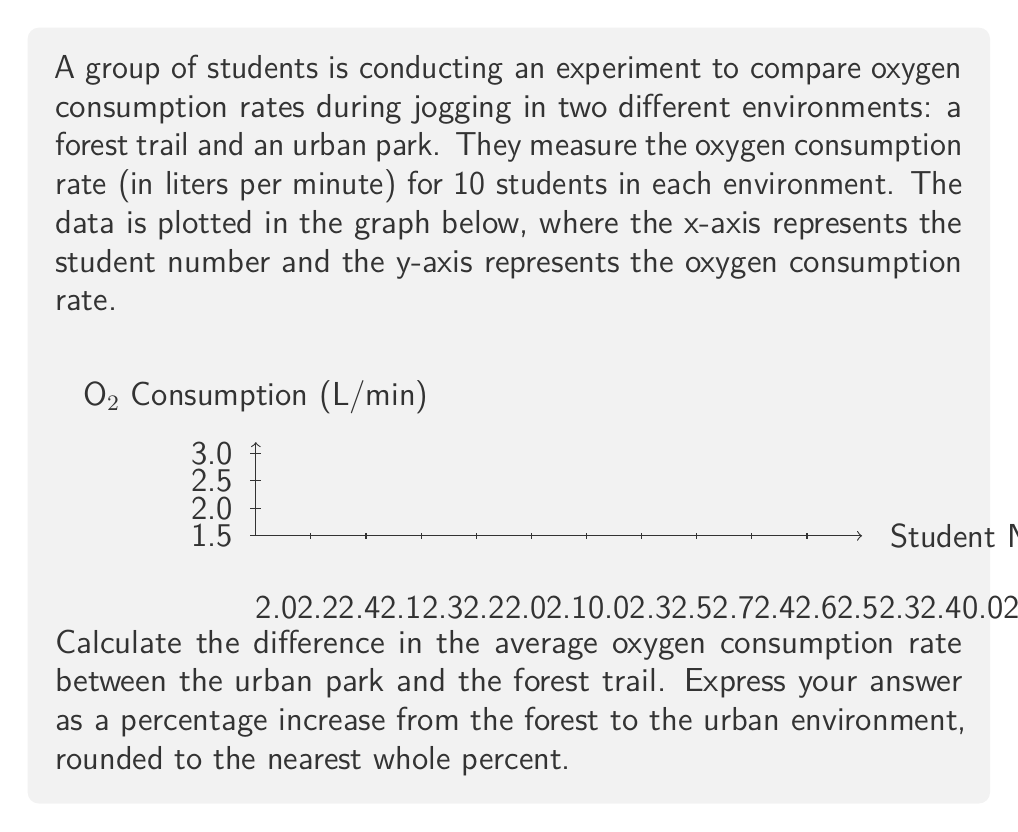Solve this math problem. Let's approach this step-by-step:

1) First, we need to calculate the average oxygen consumption rate for each environment.

   For the forest trail:
   $$\text{Forest Average} = \frac{2.1 + 2.3 + 2.0 + 2.2 + 2.4 + 2.1 + 2.3 + 2.2 + 2.0 + 2.1}{10} = \frac{21.7}{10} = 2.17 \text{ L/min}$$

   For the urban park:
   $$\text{Urban Average} = \frac{2.4 + 2.6 + 2.3 + 2.5 + 2.7 + 2.4 + 2.6 + 2.5 + 2.3 + 2.4}{10} = \frac{24.7}{10} = 2.47 \text{ L/min}$$

2) Now, we need to calculate the difference between these averages:
   $$\text{Difference} = 2.47 - 2.17 = 0.30 \text{ L/min}$$

3) To express this as a percentage increase from the forest to the urban environment, we use the formula:
   $$\text{Percentage Increase} = \frac{\text{Increase}}{\text{Original Value}} \times 100\%$$

   $$\text{Percentage Increase} = \frac{0.30}{2.17} \times 100\% = 0.1382 \times 100\% = 13.82\%$$

4) Rounding to the nearest whole percent gives us 14%.
Answer: 14% 